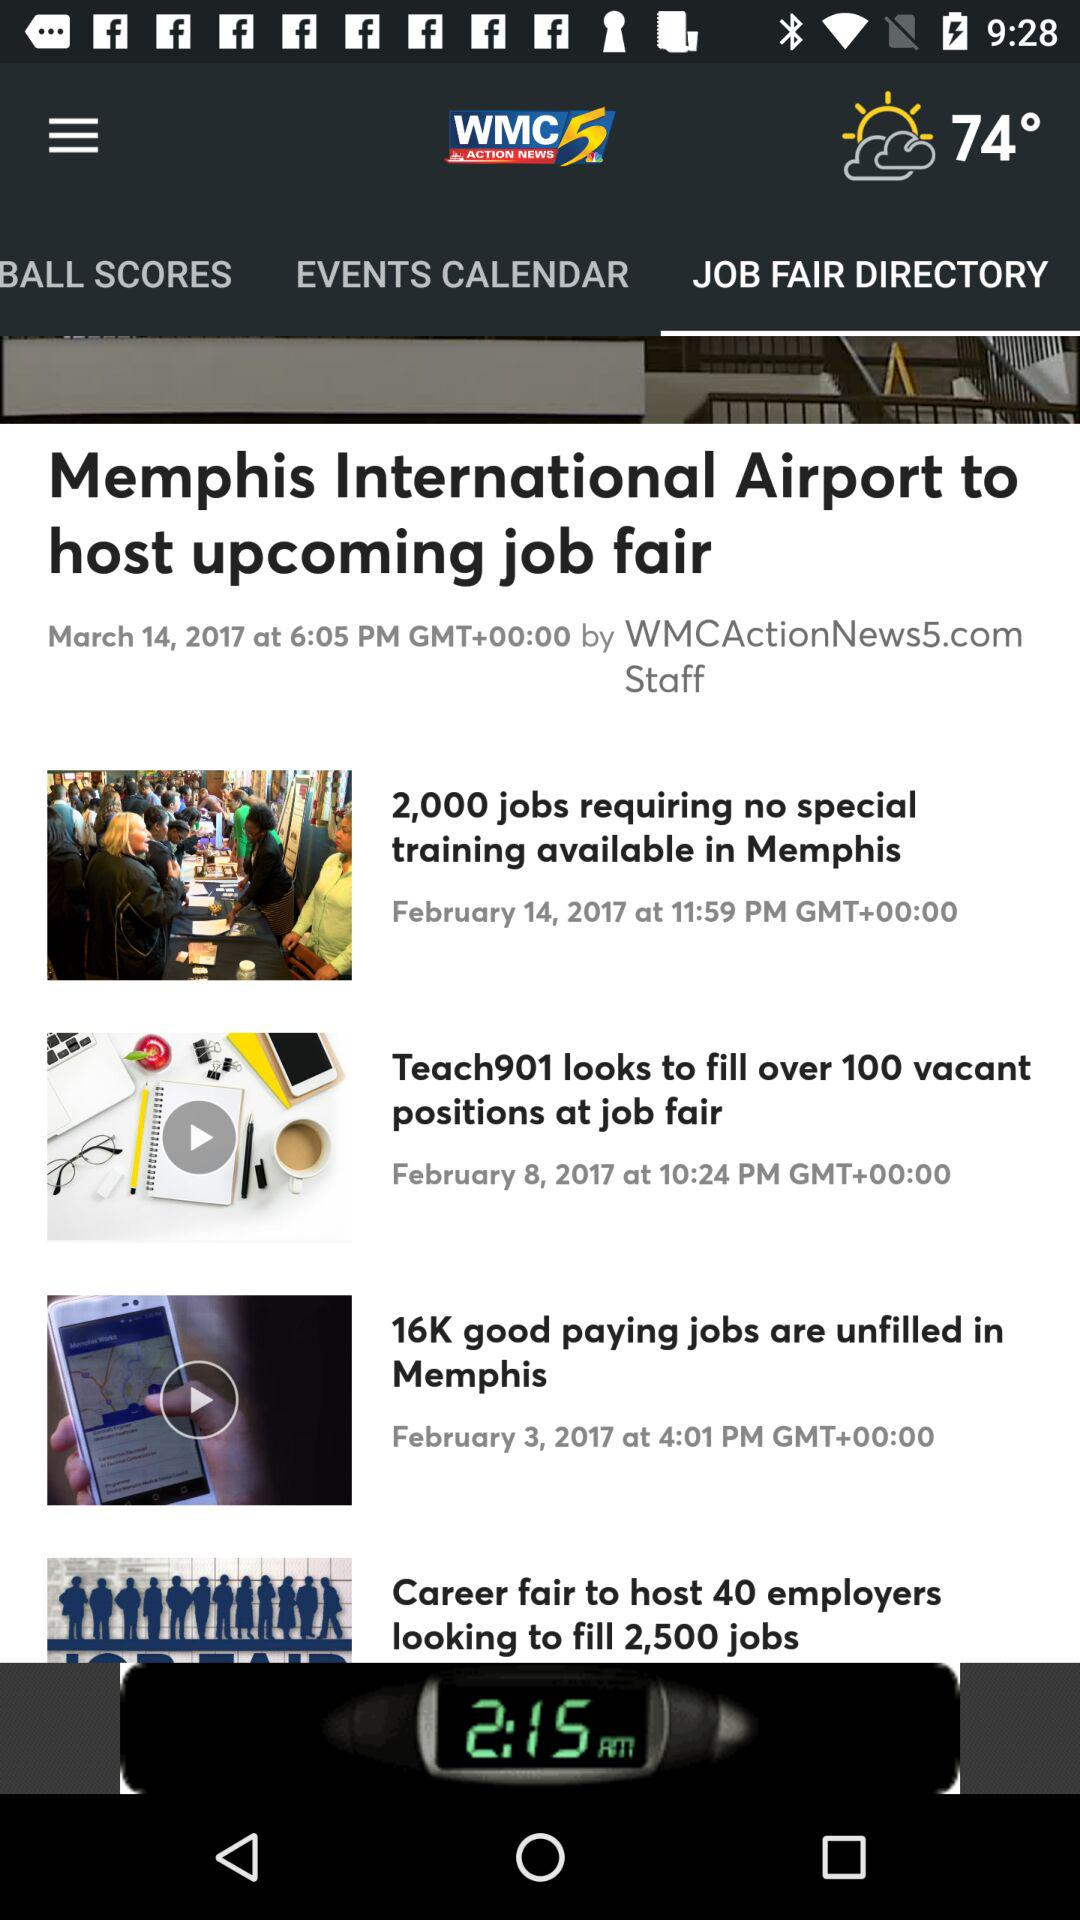How many more job fairs are scheduled for February than March?
Answer the question using a single word or phrase. 2 